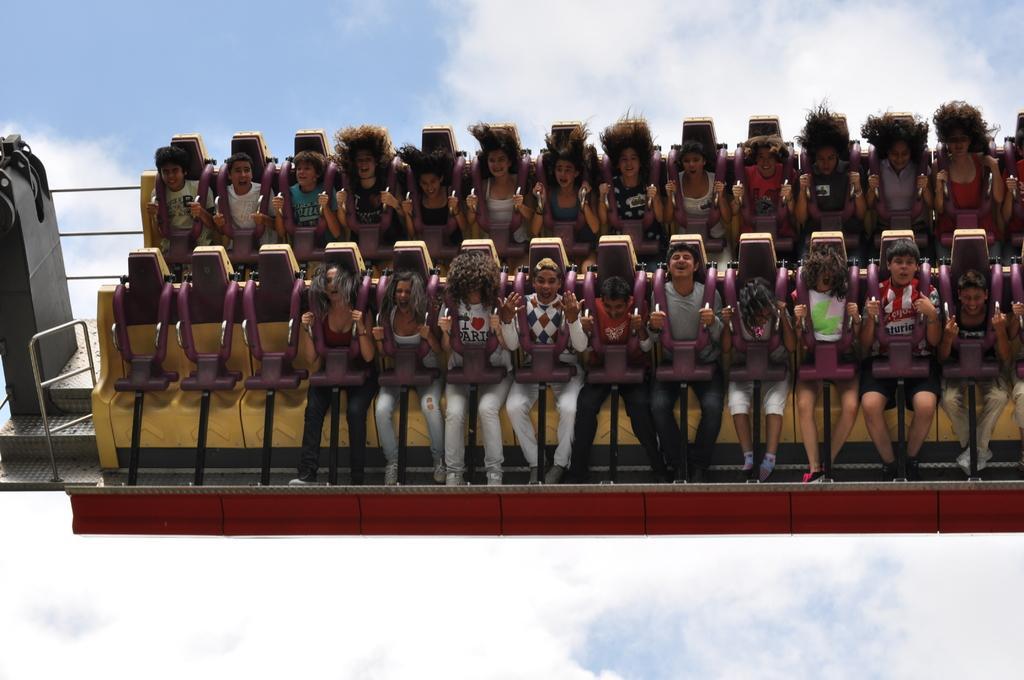Describe this image in one or two sentences. In this image there are people sitting on chairs, in the background there is the sky. 